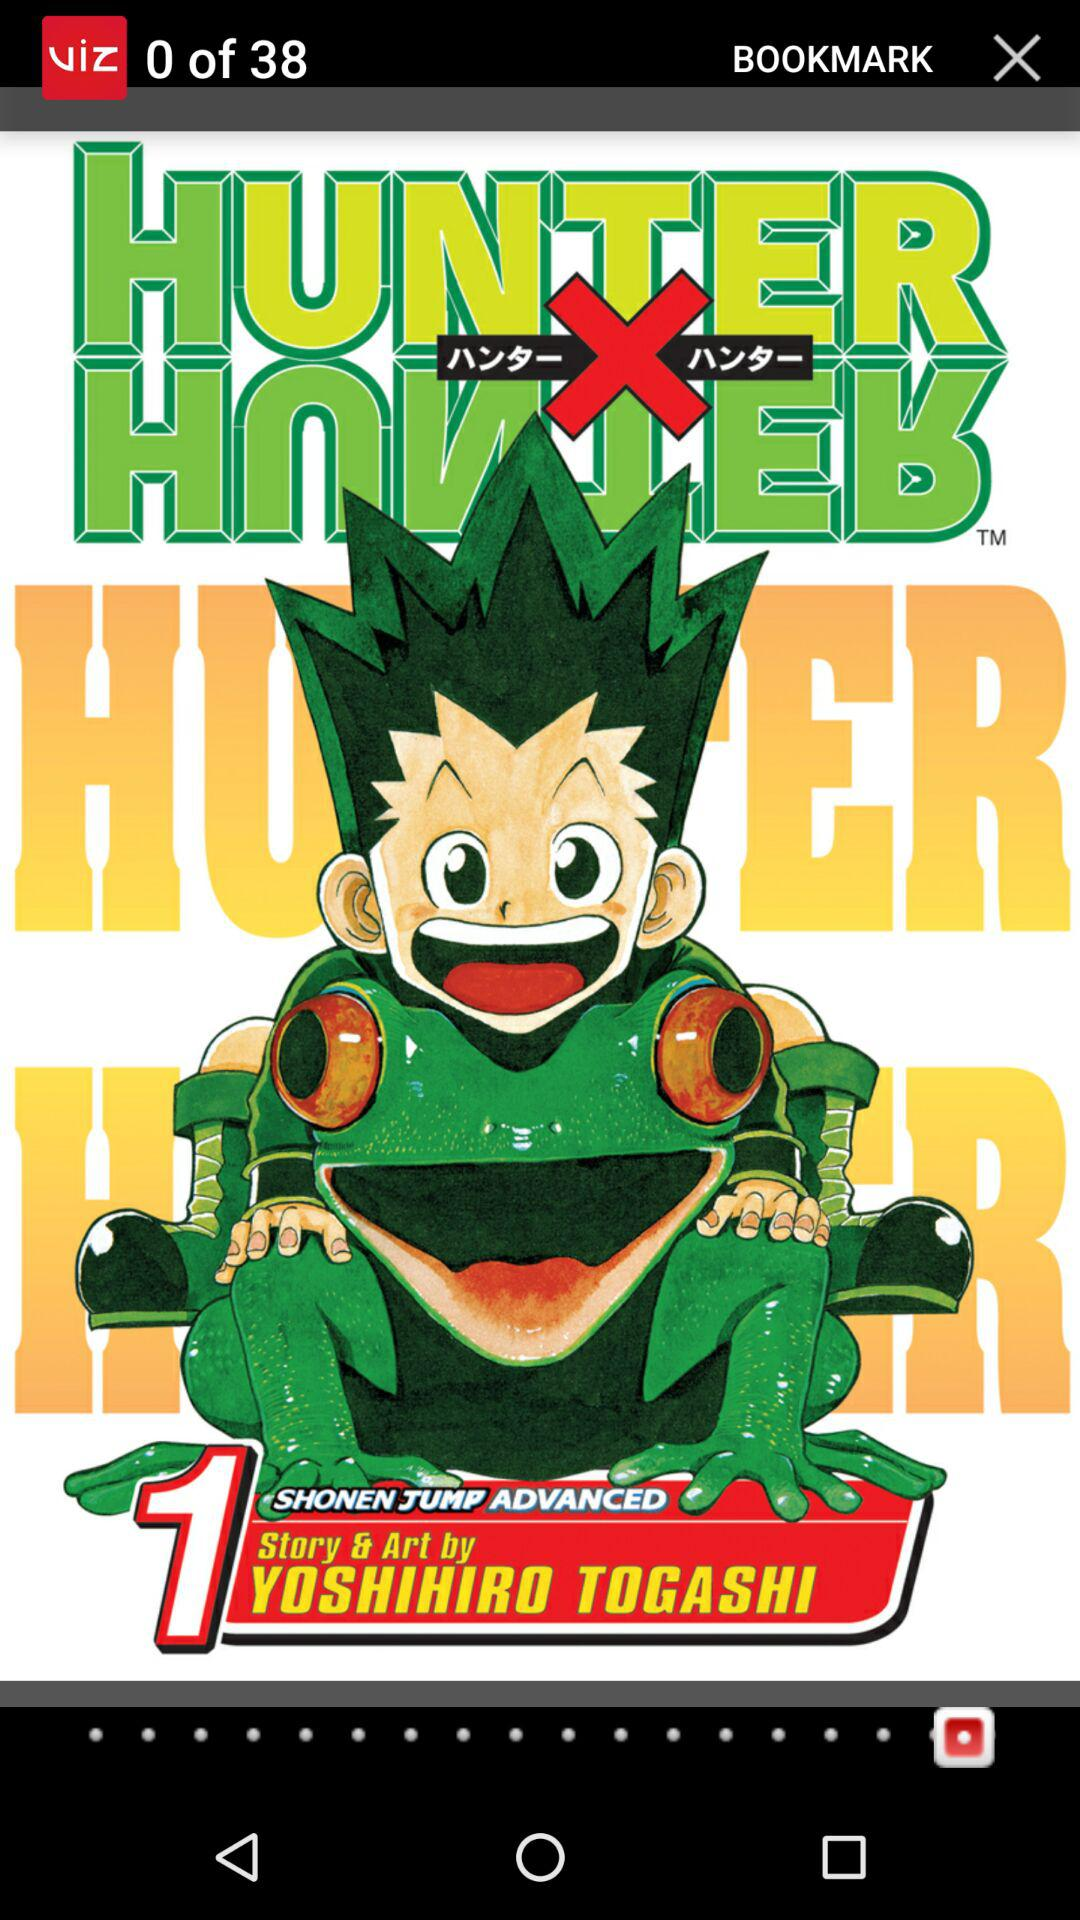When was the manga published?
When the provided information is insufficient, respond with <no answer>. <no answer> 